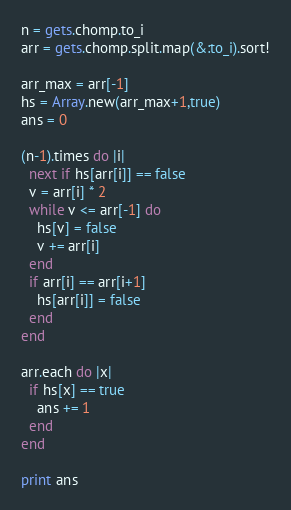<code> <loc_0><loc_0><loc_500><loc_500><_Ruby_>n = gets.chomp.to_i
arr = gets.chomp.split.map(&:to_i).sort!

arr_max = arr[-1]
hs = Array.new(arr_max+1,true)
ans = 0

(n-1).times do |i|
  next if hs[arr[i]] == false
  v = arr[i] * 2
  while v <= arr[-1] do
    hs[v] = false
    v += arr[i]
  end
  if arr[i] == arr[i+1]
    hs[arr[i]] = false
  end
end

arr.each do |x|
  if hs[x] == true
    ans += 1
  end
end

print ans</code> 